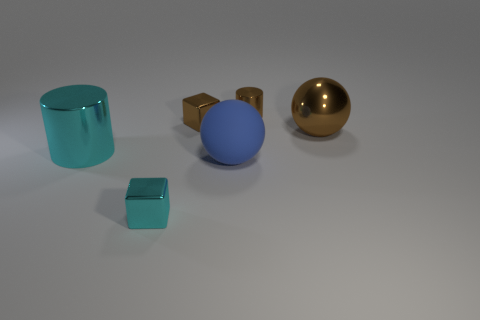Is there anything else that is made of the same material as the big blue sphere?
Offer a very short reply. No. Is there a cyan cylinder that has the same material as the big brown thing?
Your answer should be compact. Yes. The brown metallic ball is what size?
Your answer should be very brief. Large. What is the size of the sphere that is in front of the metal cylinder in front of the brown metallic cube?
Your response must be concise. Large. There is another large object that is the same shape as the matte object; what material is it?
Your answer should be compact. Metal. How many tiny red cylinders are there?
Your answer should be very brief. 0. What color is the ball that is on the right side of the cylinder that is right of the cyan thing on the right side of the big cyan thing?
Your response must be concise. Brown. Are there fewer metal objects than objects?
Provide a succinct answer. Yes. The other object that is the same shape as the small cyan metallic object is what color?
Your response must be concise. Brown. There is a big cylinder that is the same material as the big brown object; what color is it?
Give a very brief answer. Cyan. 